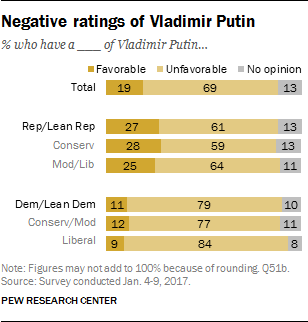Outline some significant characteristics in this image. The difference in the value of the largest grey bar and the largest dark orange bar is 15. The color of the favorable bars is dark orange. 